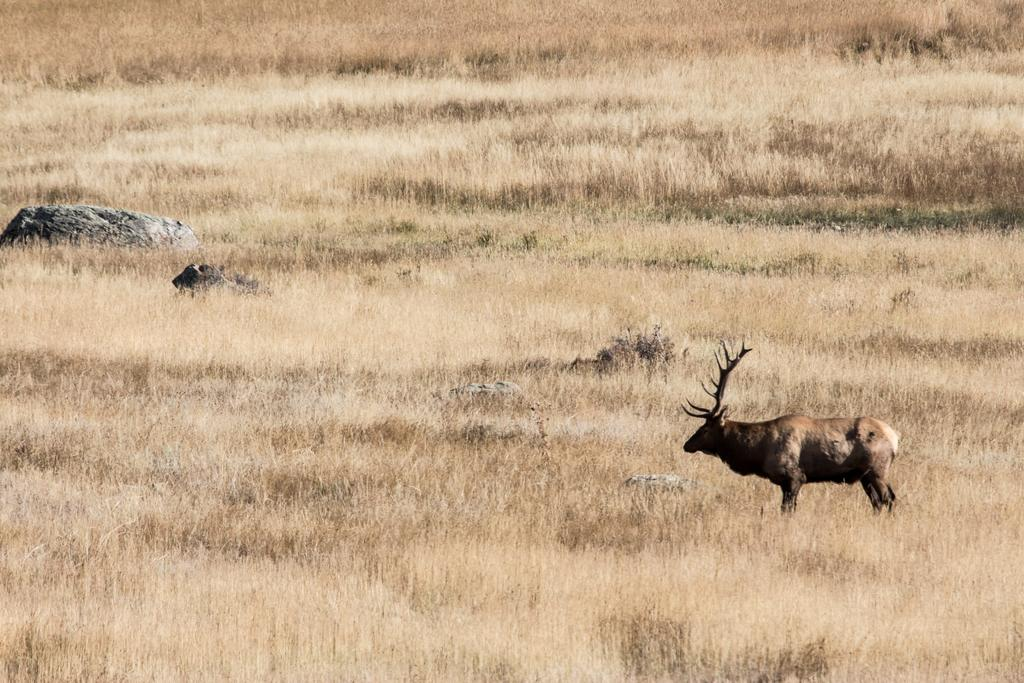What animal can be seen in the image? There is a deer in the image. Where is the deer located in the image? The deer is standing in the middle of grass. What object is beside the deer? There is a stone beside the deer. How many legs does the mother have in the image? There is no mother or any reference to a mother in the image, and therefore no legs can be counted. 